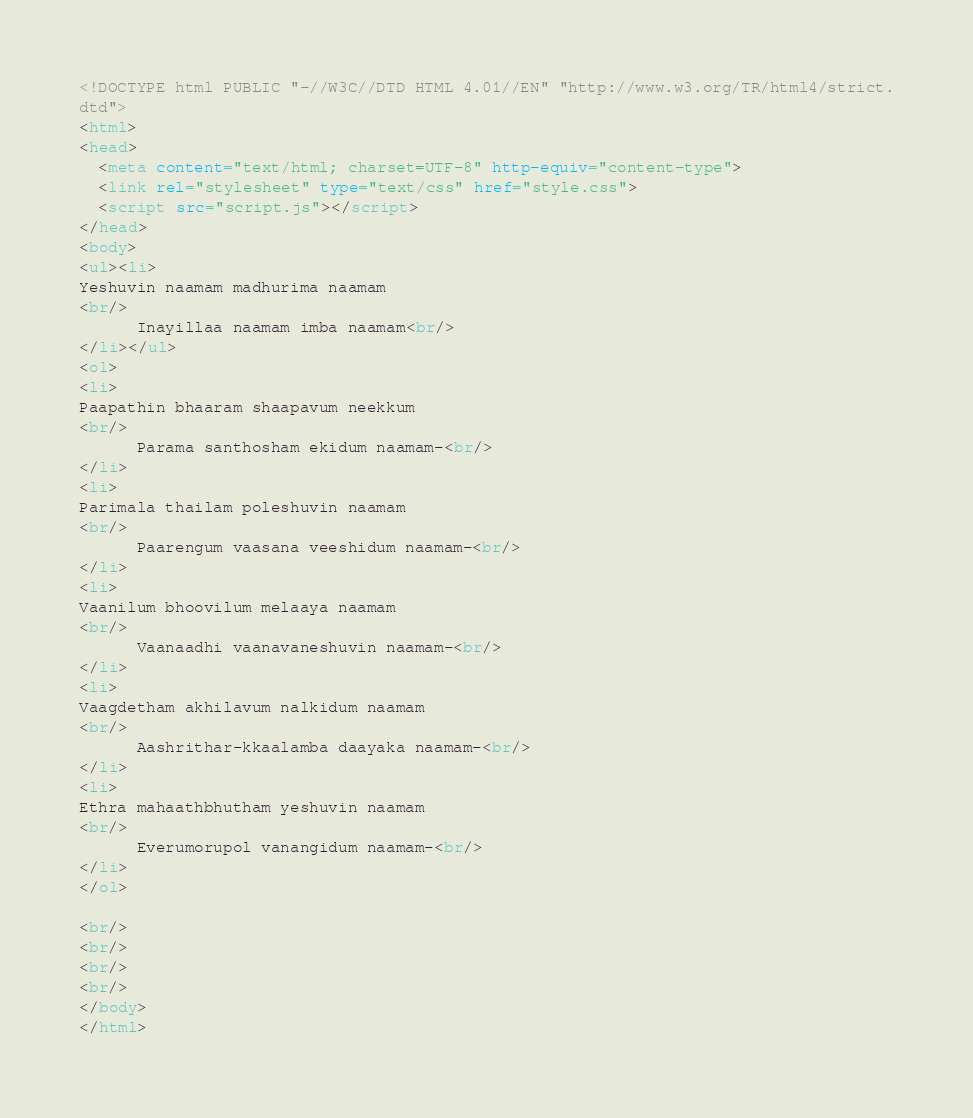Convert code to text. <code><loc_0><loc_0><loc_500><loc_500><_HTML_><!DOCTYPE html PUBLIC "-//W3C//DTD HTML 4.01//EN" "http://www.w3.org/TR/html4/strict.
dtd">
<html>
<head>
  <meta content="text/html; charset=UTF-8" http-equiv="content-type">
  <link rel="stylesheet" type="text/css" href="style.css">
  <script src="script.js"></script>
</head>
<body>
<ul><li>
Yeshuvin naamam madhurima naamam<br/>
      Inayillaa naamam imba naamam<br/>
</li></ul>
<ol>
<li>
Paapathin bhaaram shaapavum neekkum<br/>
      Parama santhosham ekidum naamam-<br/>
</li>
<li>
Parimala thailam poleshuvin naamam<br/>
      Paarengum vaasana veeshidum naamam-<br/>
</li>
<li>
Vaanilum bhoovilum melaaya naamam<br/>
      Vaanaadhi vaanavaneshuvin naamam-<br/>
</li>
<li>
Vaagdetham akhilavum nalkidum naamam<br/>
      Aashrithar-kkaalamba daayaka naamam-<br/>
</li>
<li>
Ethra mahaathbhutham yeshuvin naamam<br/>
      Everumorupol vanangidum naamam-<br/>
</li>
</ol>

<br/>
<br/>
<br/>
<br/>
</body>
</html>
</code> 